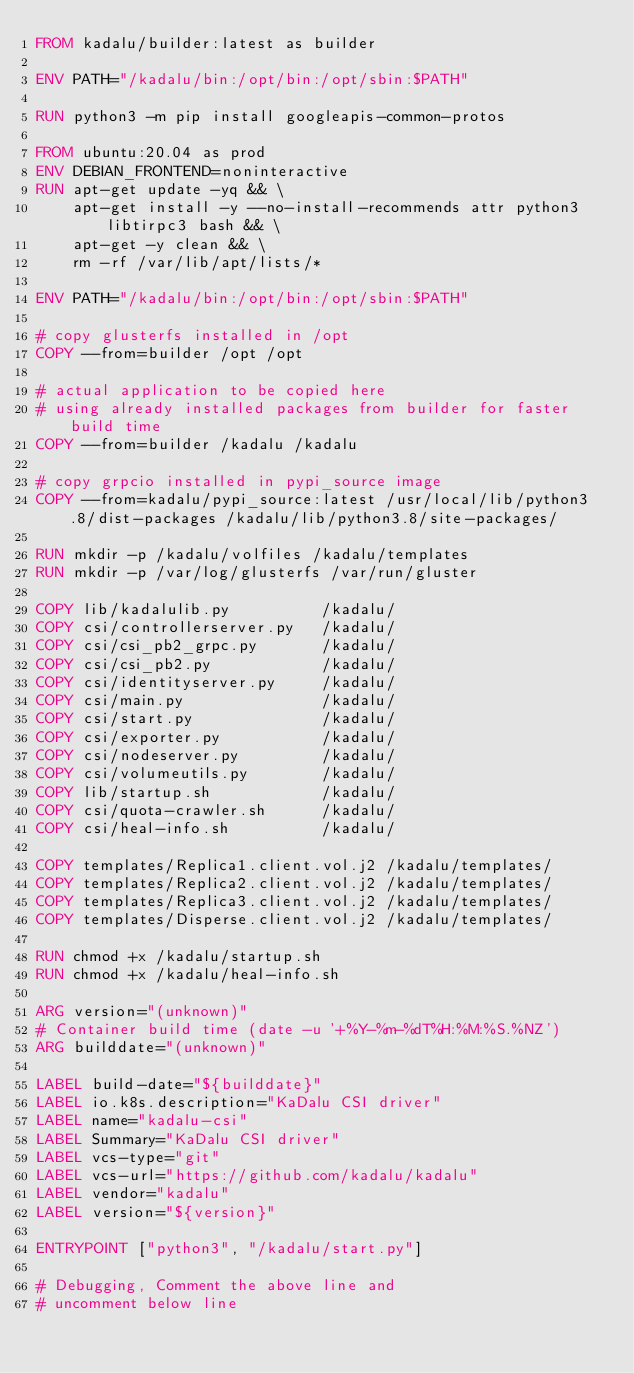<code> <loc_0><loc_0><loc_500><loc_500><_Dockerfile_>FROM kadalu/builder:latest as builder

ENV PATH="/kadalu/bin:/opt/bin:/opt/sbin:$PATH"

RUN python3 -m pip install googleapis-common-protos

FROM ubuntu:20.04 as prod
ENV DEBIAN_FRONTEND=noninteractive
RUN apt-get update -yq && \
    apt-get install -y --no-install-recommends attr python3 libtirpc3 bash && \
    apt-get -y clean && \
    rm -rf /var/lib/apt/lists/*

ENV PATH="/kadalu/bin:/opt/bin:/opt/sbin:$PATH"

# copy glusterfs installed in /opt
COPY --from=builder /opt /opt

# actual application to be copied here
# using already installed packages from builder for faster build time
COPY --from=builder /kadalu /kadalu

# copy grpcio installed in pypi_source image
COPY --from=kadalu/pypi_source:latest /usr/local/lib/python3.8/dist-packages /kadalu/lib/python3.8/site-packages/

RUN mkdir -p /kadalu/volfiles /kadalu/templates
RUN mkdir -p /var/log/glusterfs /var/run/gluster

COPY lib/kadalulib.py          /kadalu/
COPY csi/controllerserver.py   /kadalu/
COPY csi/csi_pb2_grpc.py       /kadalu/
COPY csi/csi_pb2.py            /kadalu/
COPY csi/identityserver.py     /kadalu/
COPY csi/main.py               /kadalu/
COPY csi/start.py              /kadalu/
COPY csi/exporter.py           /kadalu/
COPY csi/nodeserver.py         /kadalu/
COPY csi/volumeutils.py        /kadalu/
COPY lib/startup.sh            /kadalu/
COPY csi/quota-crawler.sh      /kadalu/
COPY csi/heal-info.sh          /kadalu/

COPY templates/Replica1.client.vol.j2 /kadalu/templates/
COPY templates/Replica2.client.vol.j2 /kadalu/templates/
COPY templates/Replica3.client.vol.j2 /kadalu/templates/
COPY templates/Disperse.client.vol.j2 /kadalu/templates/

RUN chmod +x /kadalu/startup.sh
RUN chmod +x /kadalu/heal-info.sh

ARG version="(unknown)"
# Container build time (date -u '+%Y-%m-%dT%H:%M:%S.%NZ')
ARG builddate="(unknown)"

LABEL build-date="${builddate}"
LABEL io.k8s.description="KaDalu CSI driver"
LABEL name="kadalu-csi"
LABEL Summary="KaDalu CSI driver"
LABEL vcs-type="git"
LABEL vcs-url="https://github.com/kadalu/kadalu"
LABEL vendor="kadalu"
LABEL version="${version}"

ENTRYPOINT ["python3", "/kadalu/start.py"]

# Debugging, Comment the above line and
# uncomment below line</code> 